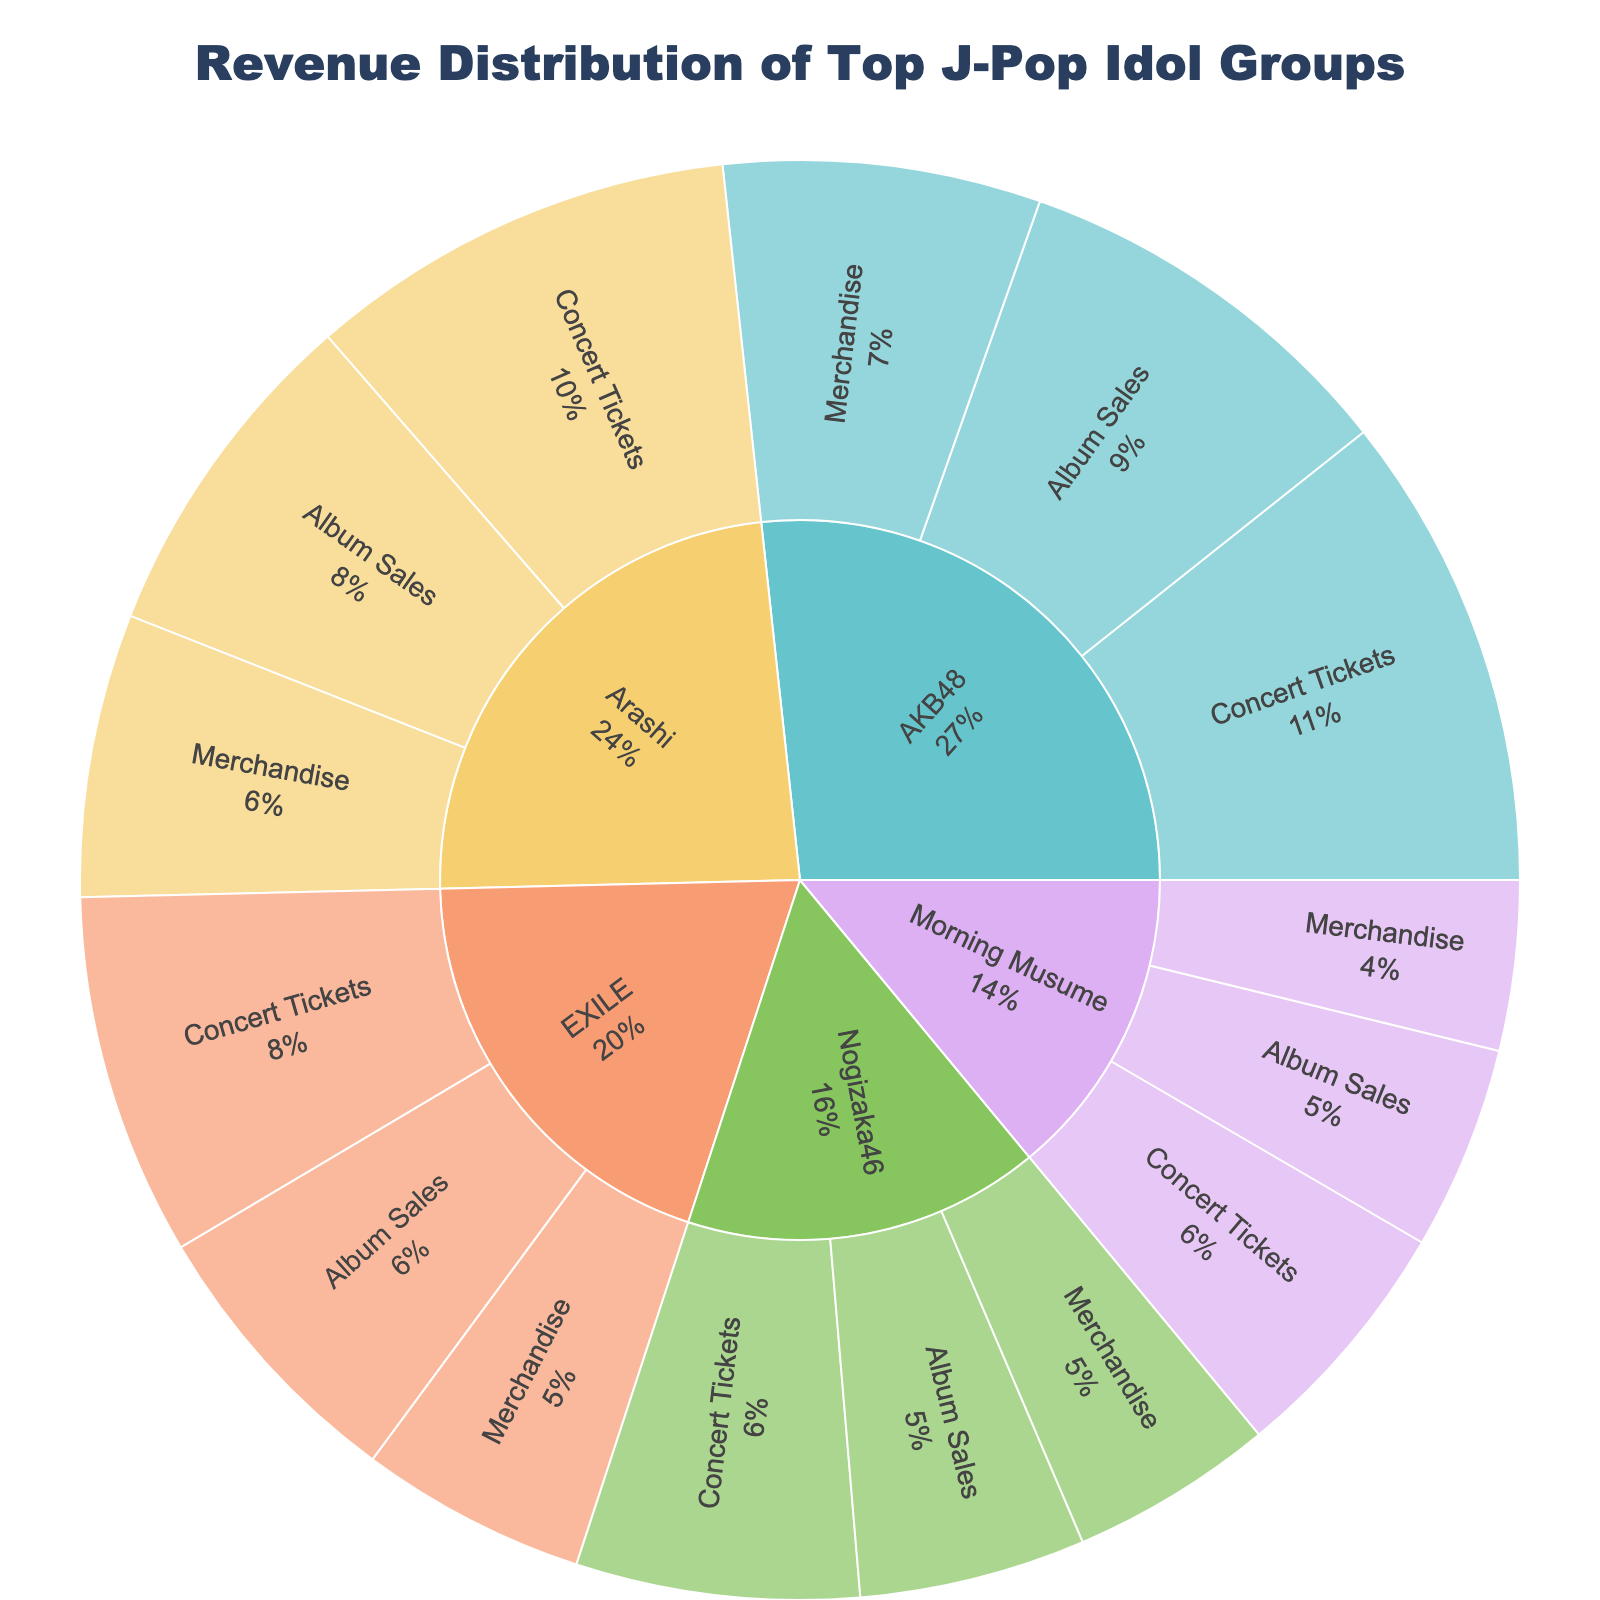What's the total revenue generated by AKB48? To find the total revenue, sum the values of Album Sales, Merchandise, and Concert Tickets for AKB48: 35,000,000 + 28,000,000 + 42,000,000 = ¥105,000,000
Answer: ¥105,000,000 Which J-Pop idol group has the highest revenue from Album Sales? Compare the Album Sales values for each group: AKB48 (¥35,000,000), Arashi (¥30,000,000), Morning Musume (¥18,000,000), EXILE (¥25,000,000), Nogizaka46 (¥20,000,000). AKB48 has the highest revenue
Answer: AKB48 What percentage of Arashi's total revenue comes from Concert Tickets? First, calculate Arashi's total revenue: 30,000,000 (Album Sales) + 25,000,000 (Merchandise) + 38,000,000 (Concert Tickets) = ¥93,000,000. Then, calculate the percentage: (38,000,000 / 93,000,000) * 100 ≈ 40.86%
Answer: ≈ 40.86% How does Morning Musume's Merchandise revenue compare to EXILE's Merchandise revenue? Compare the Merchandise values: Morning Musume (¥15,000,000) and EXILE (¥20,000,000). EXILE's Merchandise revenue is greater
Answer: EXILE's is greater What is the ratio of AKB48's Concert Tickets revenue to Nogizaka46's Concert Tickets revenue? The Concert Tickets revenue for AKB48 is ¥42,000,000 and for Nogizaka46 is ¥25,000,000. The ratio is 42,000,000 / 25,000,000 = 1.68
Answer: 1.68 Compare the total revenues from Merchandise for all groups. Which group has the highest revenue from Merchandise? Sum the Merchandise values: AKB48 (¥28,000,000), Arashi (¥25,000,000), Morning Musume (¥15,000,000), EXILE (¥20,000,000), Nogizaka46 (¥18,000,000). AKB48 has the highest Merchandise revenue
Answer: AKB48 What is the combined revenue from Album Sales for all groups? Sum the Album Sales values for each group: 35,000,000 (AKB48) + 30,000,000 (Arashi) + 18,000,000 (Morning Musume) + 25,000,000 (EXILE) + 20,000,000 (Nogizaka46) = ¥128,000,000
Answer: ¥128,000,000 Which group has the smallest total revenue, and what is the amount? Calculate the total revenue for each group and find the smallest: AKB48 (¥105,000,000), Arashi (¥93,000,000), Morning Musume (¥55,000,000), EXILE (¥77,000,000), Nogizaka46 (¥63,000,000). Morning Musume has the smallest total revenue
Answer: Morning Musume, ¥55,000,000 